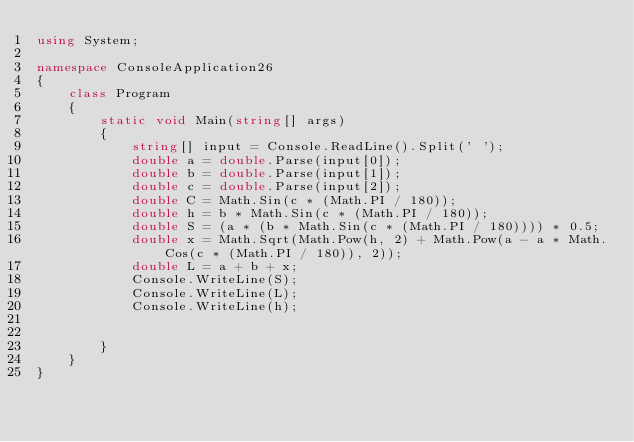<code> <loc_0><loc_0><loc_500><loc_500><_C#_>using System;

namespace ConsoleApplication26
{
    class Program
    {
        static void Main(string[] args)
        {
            string[] input = Console.ReadLine().Split(' ');
            double a = double.Parse(input[0]);
            double b = double.Parse(input[1]);
            double c = double.Parse(input[2]);
            double C = Math.Sin(c * (Math.PI / 180));
            double h = b * Math.Sin(c * (Math.PI / 180));
            double S = (a * (b * Math.Sin(c * (Math.PI / 180)))) * 0.5;
            double x = Math.Sqrt(Math.Pow(h, 2) + Math.Pow(a - a * Math.Cos(c * (Math.PI / 180)), 2));
            double L = a + b + x;
            Console.WriteLine(S);
            Console.WriteLine(L);
            Console.WriteLine(h);


        }
    }
}</code> 